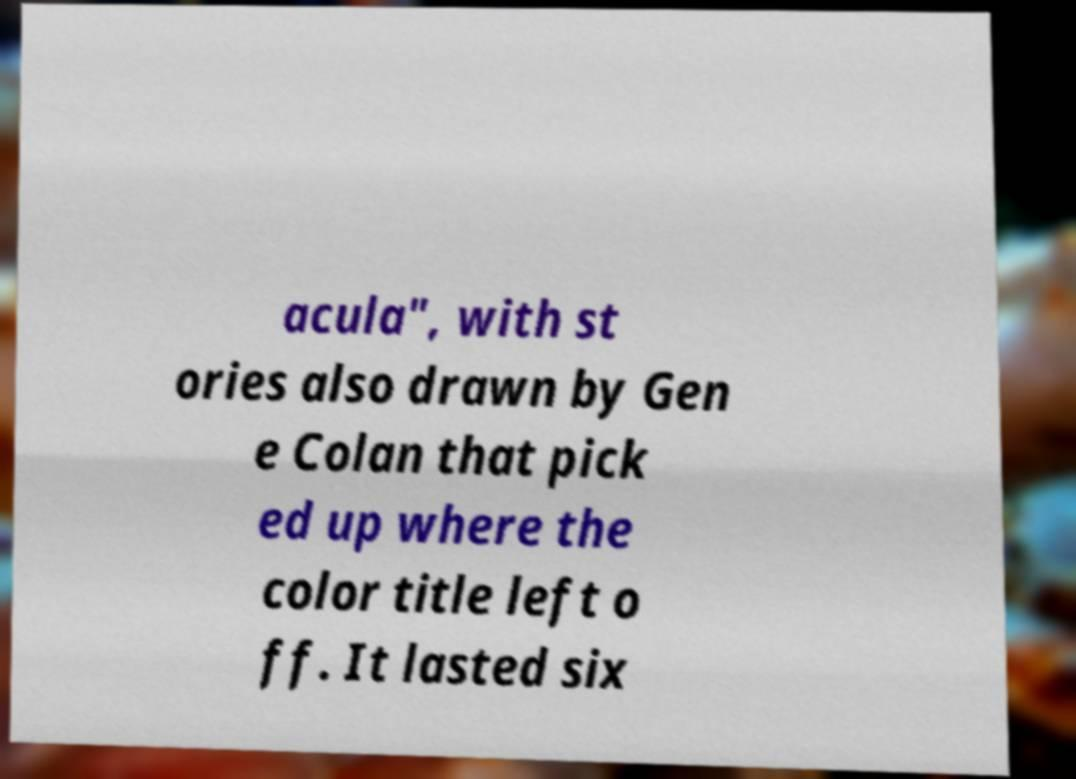Could you extract and type out the text from this image? acula", with st ories also drawn by Gen e Colan that pick ed up where the color title left o ff. It lasted six 